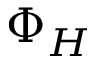<formula> <loc_0><loc_0><loc_500><loc_500>\Phi _ { H }</formula> 